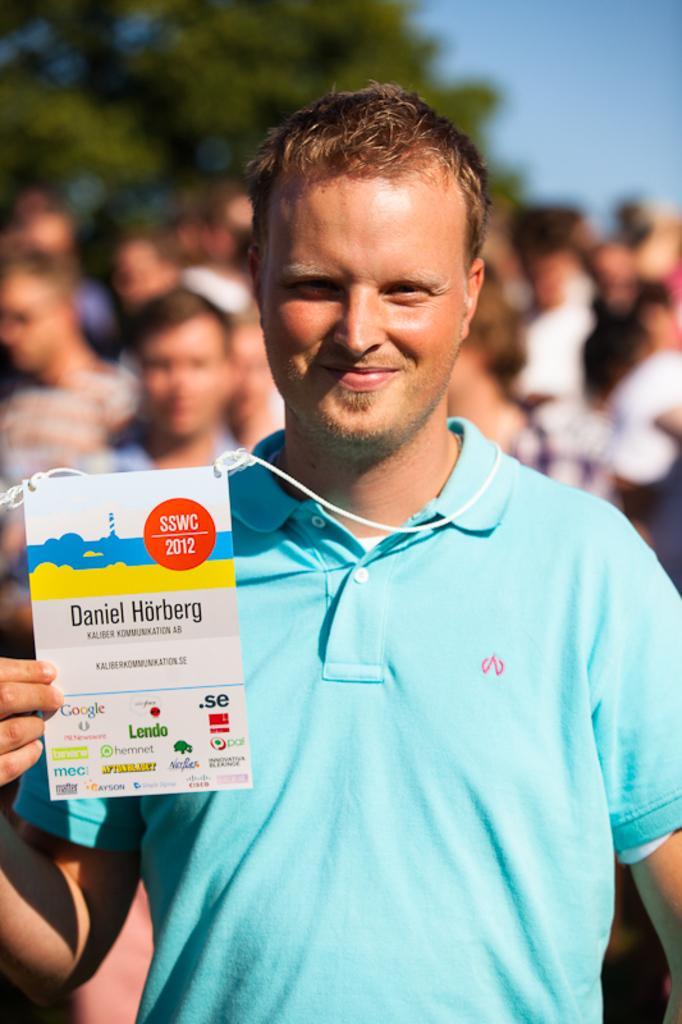In one or two sentences, can you explain what this image depicts? In the image we can see there is a person standing and he is holding an id card in his hand. Behind there are other people standing and the image is blur at the back. 